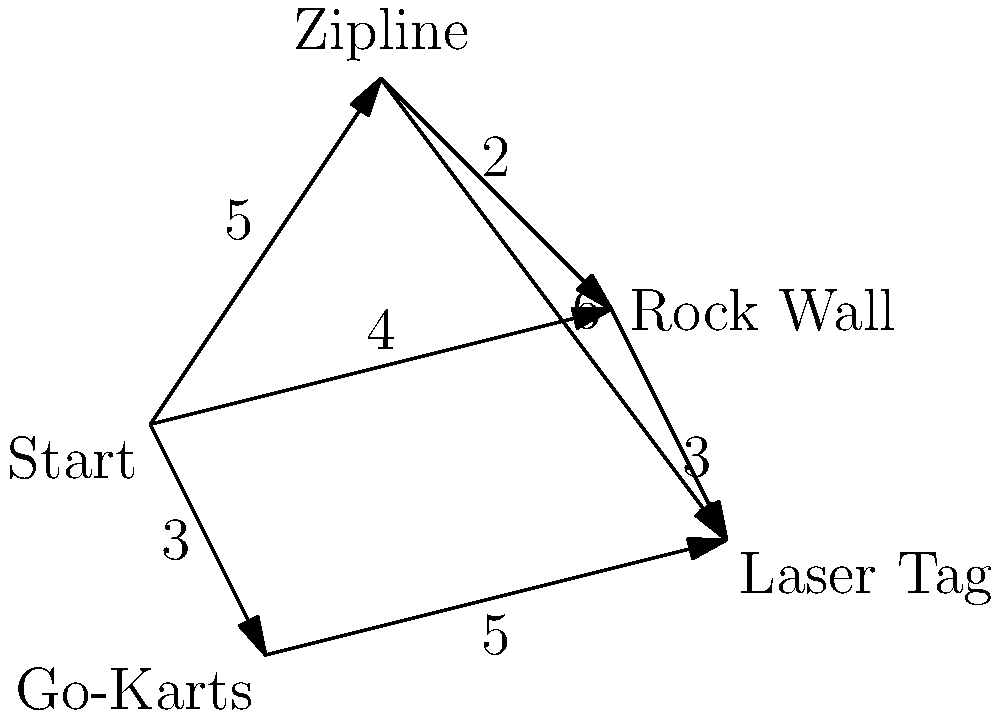In an adventure park, you want to experience all the exciting activities in the shortest possible time. The graph shows the travel times (in minutes) between different activities. What is the minimum time required to visit all activities, starting from "Start" and ending at "Laser Tag"? To find the shortest path visiting all activities, we need to use the concept of the Traveling Salesman Problem (TSP) with a fixed start and end point. Here's how we can solve it:

1. Identify all possible paths:
   - Start → Zipline → Rock Wall → Go-Karts → Laser Tag
   - Start → Zipline → Go-Karts → Rock Wall → Laser Tag
   - Start → Rock Wall → Zipline → Go-Karts → Laser Tag
   - Start → Rock Wall → Go-Karts → Zipline → Laser Tag
   - Start → Go-Karts → Zipline → Rock Wall → Laser Tag
   - Start → Go-Karts → Rock Wall → Zipline → Laser Tag

2. Calculate the total time for each path:
   - Path 1: 5 + 2 + 5 + 5 = 17 minutes
   - Path 2: 5 + 6 + 5 + 3 = 19 minutes
   - Path 3: 4 + 2 + 5 + 5 = 16 minutes
   - Path 4: 4 + 3 + 5 + 6 = 18 minutes
   - Path 5: 3 + 5 + 2 + 3 = 13 minutes
   - Path 6: 3 + 4 + 2 + 6 = 15 minutes

3. Identify the shortest path:
   The shortest path is Path 5: Start → Go-Karts → Zipline → Rock Wall → Laser Tag, with a total time of 13 minutes.
Answer: 13 minutes 